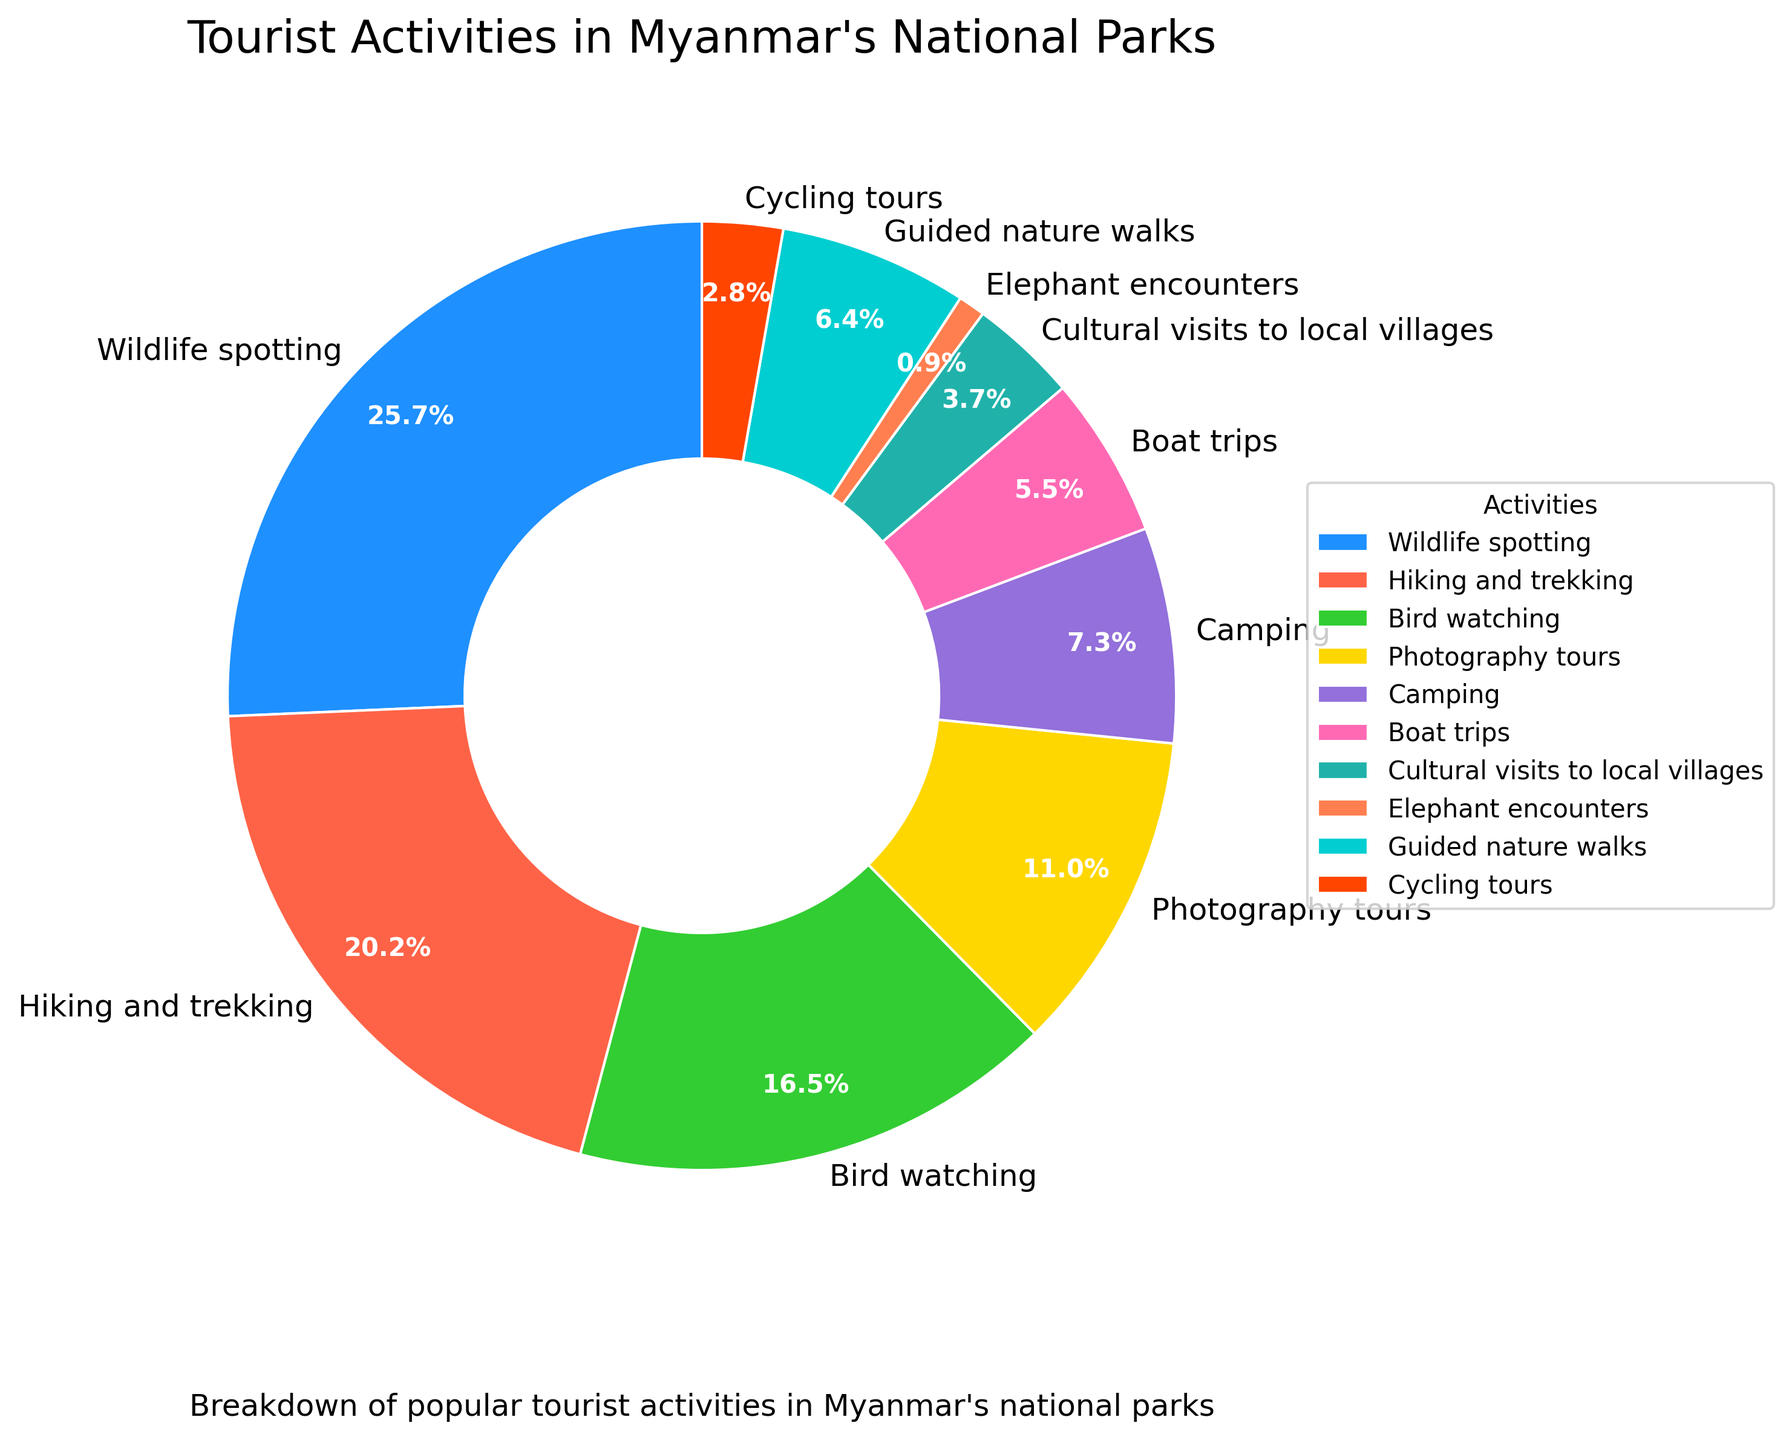What is the most popular tourist activity in Myanmar's national parks? The pie chart shows the percentage breakdown of various tourist activities. The largest section is labeled "Wildlife spotting" with 28%.
Answer: Wildlife spotting Which activity has the smallest percentage, and what is it? From the pie chart, the smallest segment is labeled "Elephant encounters," and its percentage is 1%.
Answer: Elephant encounters What is the combined percentage of Hiking and trekking, and Bird watching? By looking at the pie chart, "Hiking and trekking" is 22% and "Bird watching" is 18%. Adding these together 22% + 18% = 40%.
Answer: 40% How does the percentage of Camping compare to that of Photography tours? The pie chart shows Camping at 8% and Photography tours at 12%. Camping is less than Photography tours by 4%.
Answer: Camping is 4% less than Photography tours What are the visual differences between the sections for Wildlife spotting and Guided nature walks? Wildlife spotting is a larger section with a vibrant blue color, while Guided nature walks is smaller and colored cyan. The data labels also show Wildlife spotting at 28% and Guided nature walks at 7%.
Answer: Wildlife spotting is larger and blue; Guided nature walks is smaller and cyan Which activities combined make up more than half of the total tourist activities? Adding the percentages of Wildlife spotting (28%), Hiking and trekking (22%), Bird watching (18%), and Photography tours (12%) results in 28% + 22% + 18% + 12% = 80%. These four activities together account for more than 50% of the total.
Answer: Wildlife spotting, Hiking and trekking, Bird watching, Photography tours What is the percentage difference between Boat trips and Cultural visits to local villages? The pie chart indicates Boat trips at 6% and Cultural visits to local villages at 4%. The difference is 6% - 4% = 2%.
Answer: 2% If you were to combine Photography tours, Camping, and Guided nature walks, what percentage of the total would that be? Adding the percentages of Photography tours (12%), Camping (8%), and Guided nature walks (7%) results in 12% + 8% + 7% = 27%.
Answer: 27% Compare the popularity of Cycling tours and Elephant encounters. Cycling tours has 3% while Elephant encounters has 1%. Cycling tours is more popular, with a difference of 2%.
Answer: Cycling tours is 2% more popular than Elephant encounters 